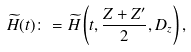<formula> <loc_0><loc_0><loc_500><loc_500>\widetilde { H } ( t ) \colon = \widetilde { H } \left ( t , \frac { Z + Z ^ { \prime } } { 2 } , D _ { z } \right ) ,</formula> 